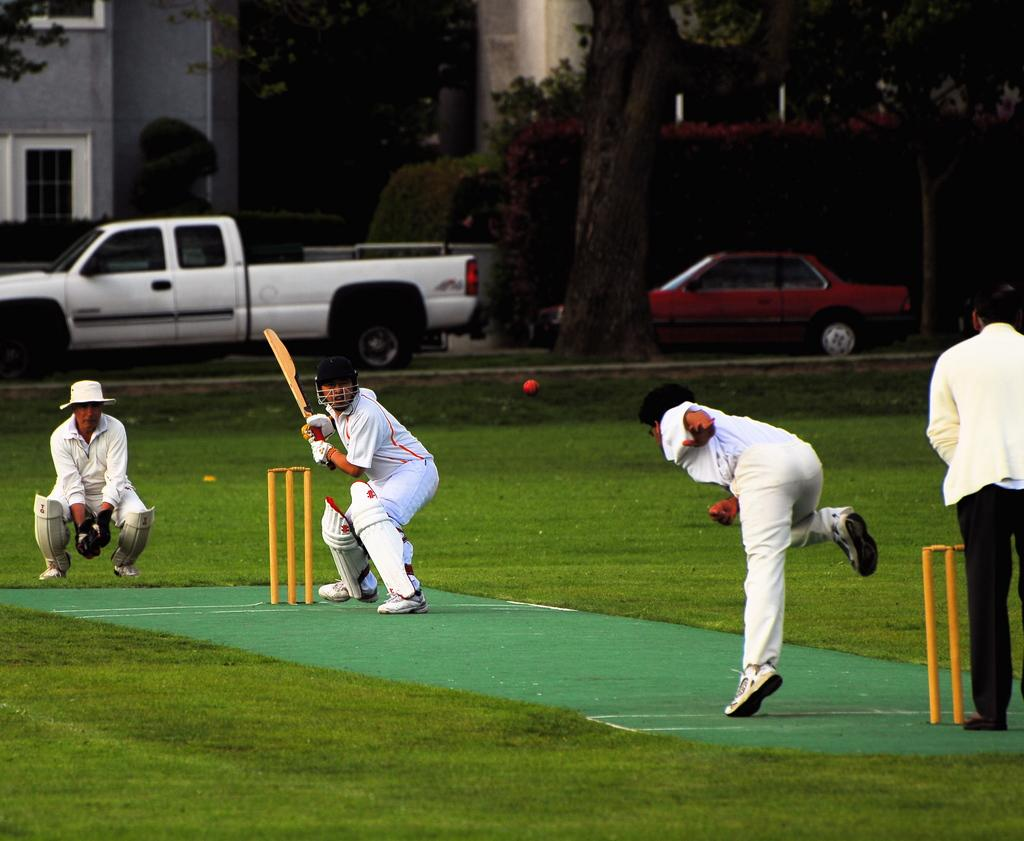What sport are the people playing in the image? The people are playing cricket in the image. What type of surface is the cricket game being played on? The cricket game is taking place on grass. What can be seen in the background of the image? There are vehicles and buildings visible in the background of the image. What type of lunch is being served during the cricket game in the image? There is no indication of lunch being served in the image; it only shows people playing cricket on grass. 